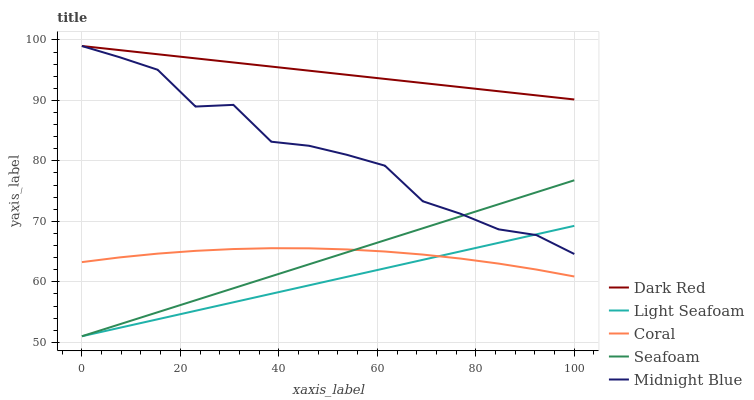Does Light Seafoam have the minimum area under the curve?
Answer yes or no. Yes. Does Dark Red have the maximum area under the curve?
Answer yes or no. Yes. Does Coral have the minimum area under the curve?
Answer yes or no. No. Does Coral have the maximum area under the curve?
Answer yes or no. No. Is Light Seafoam the smoothest?
Answer yes or no. Yes. Is Midnight Blue the roughest?
Answer yes or no. Yes. Is Coral the smoothest?
Answer yes or no. No. Is Coral the roughest?
Answer yes or no. No. Does Light Seafoam have the lowest value?
Answer yes or no. Yes. Does Coral have the lowest value?
Answer yes or no. No. Does Midnight Blue have the highest value?
Answer yes or no. Yes. Does Light Seafoam have the highest value?
Answer yes or no. No. Is Coral less than Dark Red?
Answer yes or no. Yes. Is Dark Red greater than Seafoam?
Answer yes or no. Yes. Does Light Seafoam intersect Coral?
Answer yes or no. Yes. Is Light Seafoam less than Coral?
Answer yes or no. No. Is Light Seafoam greater than Coral?
Answer yes or no. No. Does Coral intersect Dark Red?
Answer yes or no. No. 